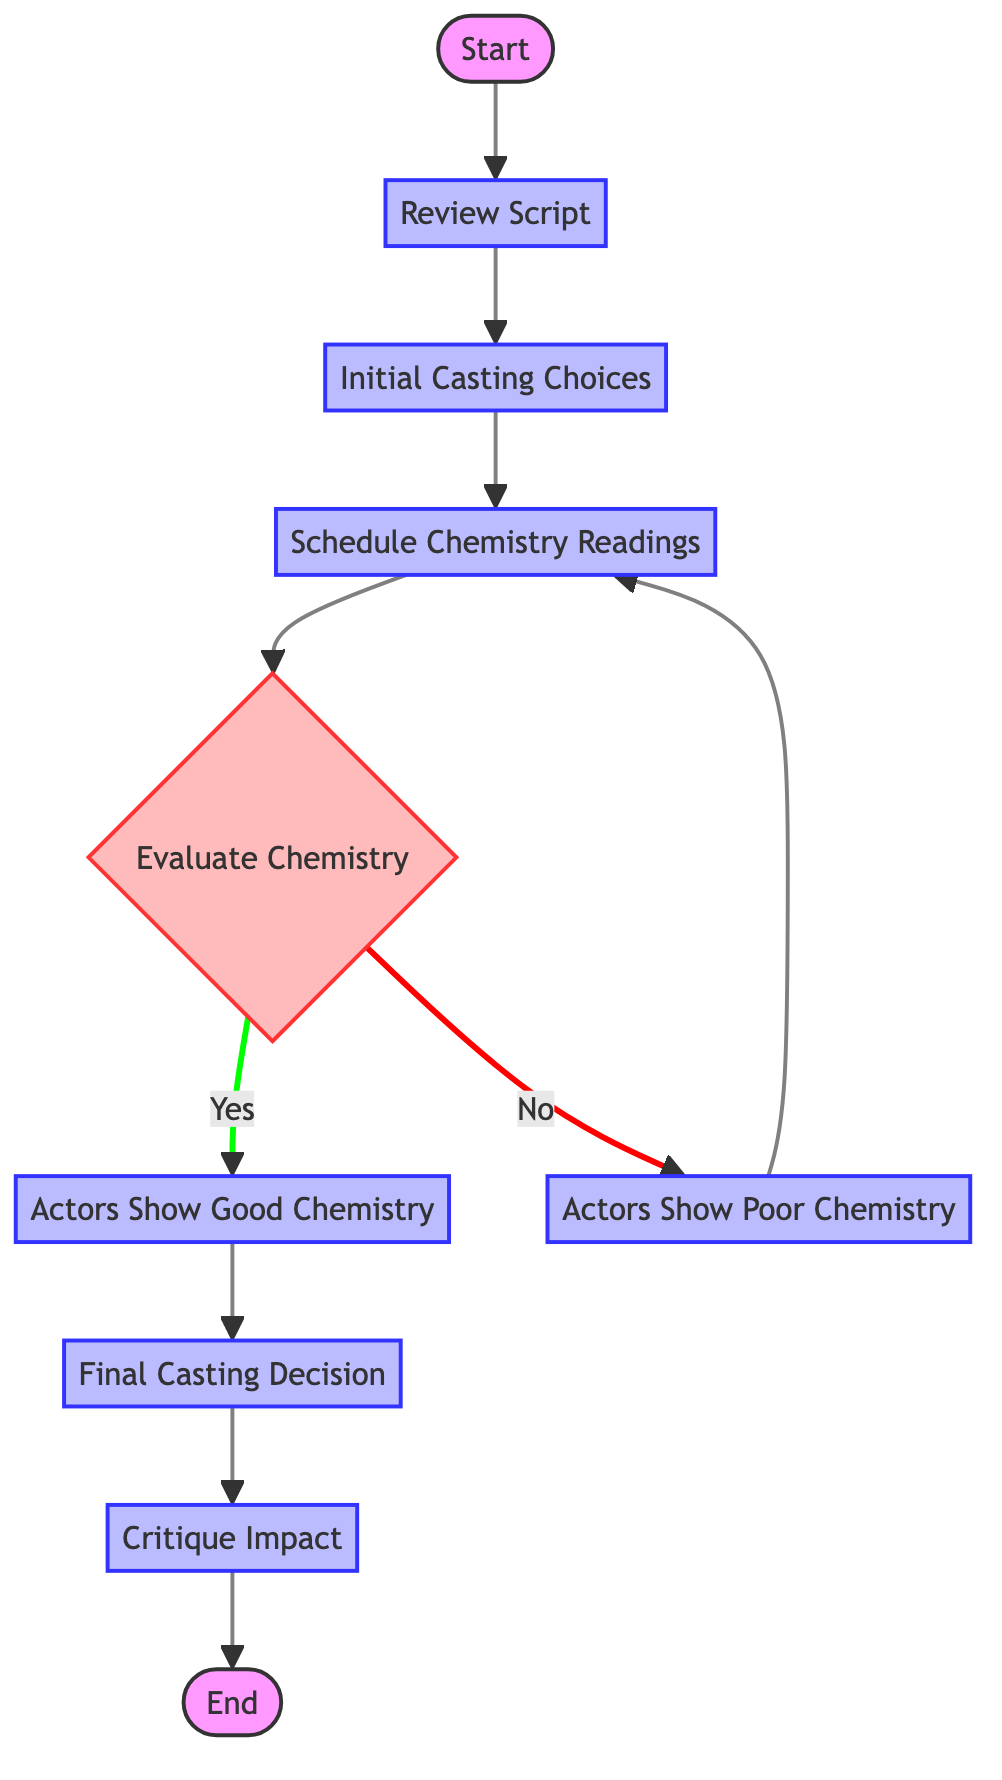What is the first step in the process? The first step as indicated in the diagram is "Review Script," which is the initial action taken to analyze the script.
Answer: Review Script How many main processes are there? Counting the processes in the diagram, there are a total of six main processes: "Review Script," "Initial Casting Choices," "Schedule Chemistry Readings," "Actors Show Good Chemistry," "Actors Show Poor Chemistry," and "Final Casting Decision."
Answer: Six What decision is made after evaluating chemistry readings? After evaluating the chemistry readings, the decision made is whether actors exhibit convincing chemistry or not.
Answer: Evaluate Chemistry What happens if the chemistry reading is poor? If the chemistry reading is poor, the diagram indicates to return to "Schedule Chemistry Readings," suggesting a reconsideration of the chemistry sessions.
Answer: Schedule Chemistry Readings Which process follows the "Actors Show Good Chemistry"? After confirming that actors show good chemistry, the next process that follows is "Final Casting Decision," where the final decisions on casting are made.
Answer: Final Casting Decision How many paths are there from the "Evaluate Chemistry" node? There are two paths from the "Evaluate Chemistry" node: one leading to "Actors Show Good Chemistry" (if yes) and another leading to "Actors Show Poor Chemistry" (if no).
Answer: Two What is the final outcome assessed in the process? The final outcome assessed in the process is the "Critique Impact," where the influence of the casting choices on the overall film is analyzed.
Answer: Critique Impact If actors show poor chemistry, what action is taken next? The next action taken if actors show poor chemistry is to "Schedule Chemistry Readings," indicating a repeat of chemistry assessments.
Answer: Schedule Chemistry Readings What is the last node in the flow diagram? The last node in the flow diagram is labeled "End," which signifies the conclusion of the entire casting process.
Answer: End 